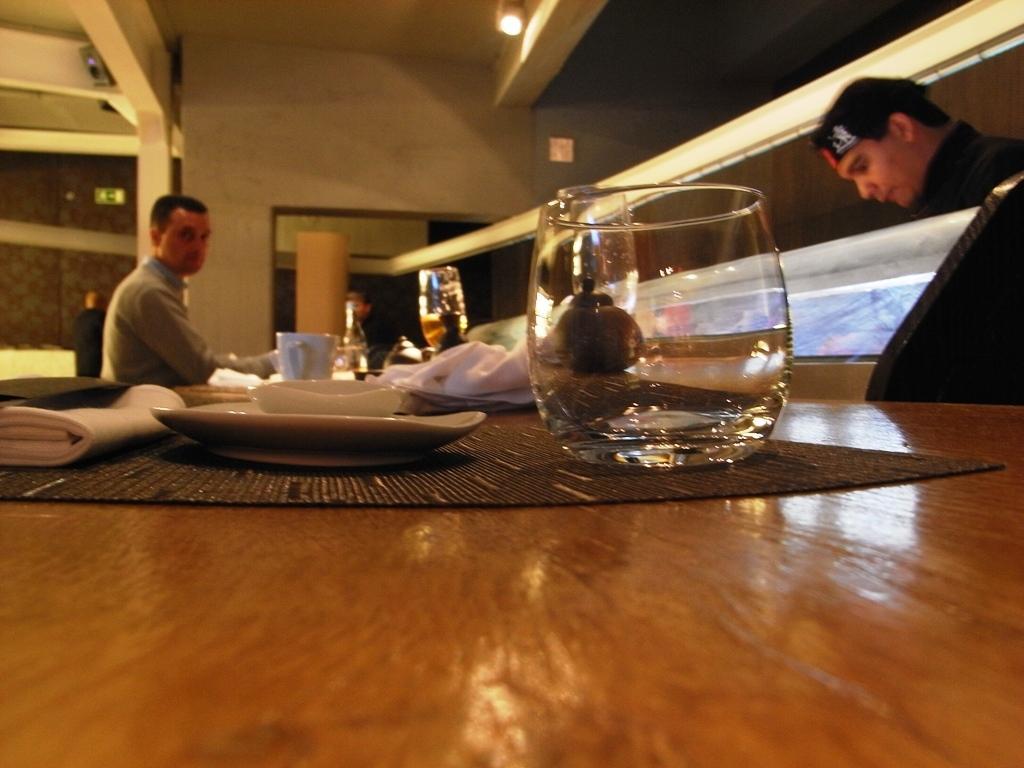Please provide a concise description of this image. An indoor picture. A light is attached with a roof. This 2 persons are standing. This man wore black cap. On a table there is a mat, cup, mug and a glass. 